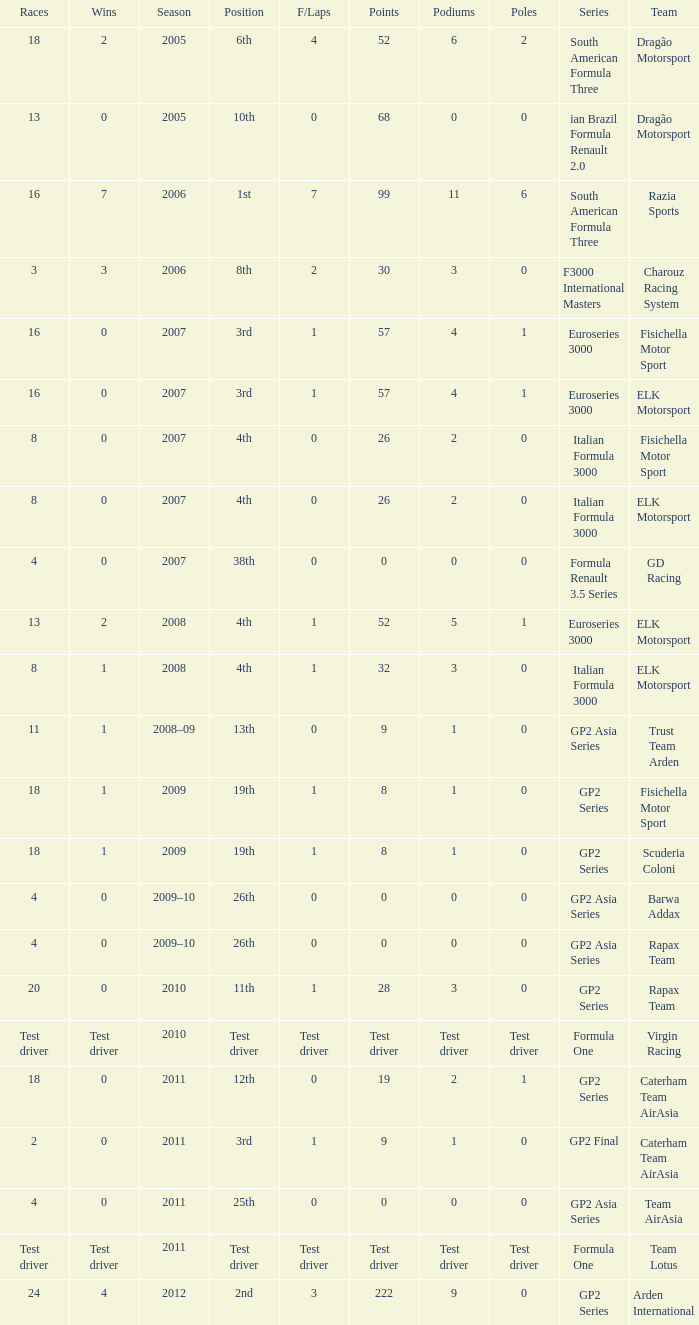In which season did he have 0 Poles and 19th position in the GP2 Series? 2009, 2009. 